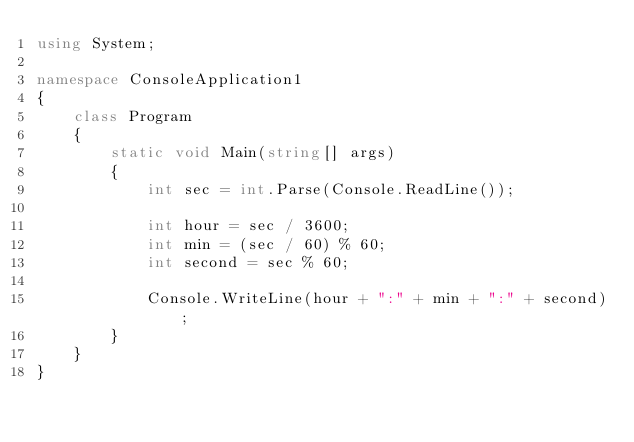Convert code to text. <code><loc_0><loc_0><loc_500><loc_500><_C#_>using System;

namespace ConsoleApplication1
{
    class Program
    {
        static void Main(string[] args)
        {
            int sec = int.Parse(Console.ReadLine());

            int hour = sec / 3600;
            int min = (sec / 60) % 60;
            int second = sec % 60;

            Console.WriteLine(hour + ":" + min + ":" + second);
        }
    }
}</code> 